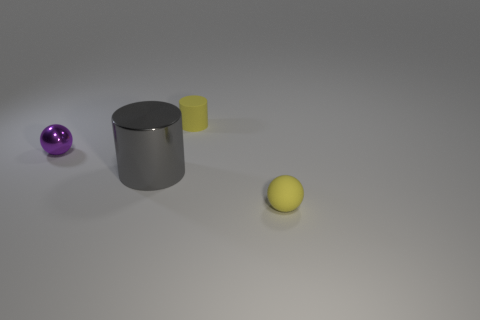There is a cylinder that is made of the same material as the purple sphere; what is its size?
Your response must be concise. Large. What is the shape of the purple shiny thing?
Your response must be concise. Sphere. Is the small purple sphere made of the same material as the yellow thing to the left of the yellow rubber ball?
Provide a succinct answer. No. How many things are yellow cylinders or tiny shiny things?
Make the answer very short. 2. Are there any small blue things?
Offer a very short reply. No. The tiny object that is on the right side of the yellow rubber thing on the left side of the small yellow rubber ball is what shape?
Make the answer very short. Sphere. What number of things are tiny objects right of the small rubber cylinder or yellow rubber things that are in front of the big object?
Offer a terse response. 1. What is the material of the other sphere that is the same size as the purple sphere?
Your answer should be very brief. Rubber. The big cylinder is what color?
Ensure brevity in your answer.  Gray. What is the material of the object that is right of the gray metallic object and behind the gray shiny object?
Provide a succinct answer. Rubber. 